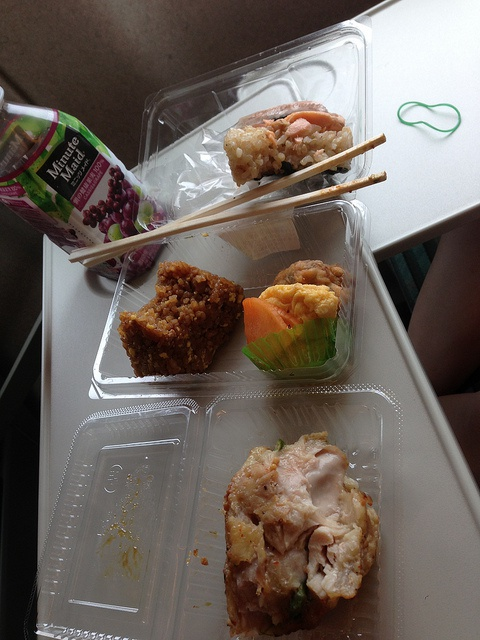Describe the objects in this image and their specific colors. I can see a bottle in black, maroon, gray, and darkgreen tones in this image. 